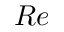<formula> <loc_0><loc_0><loc_500><loc_500>R e</formula> 